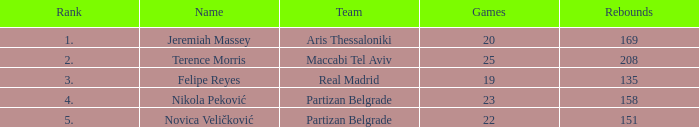How many Games for Terence Morris? 25.0. 